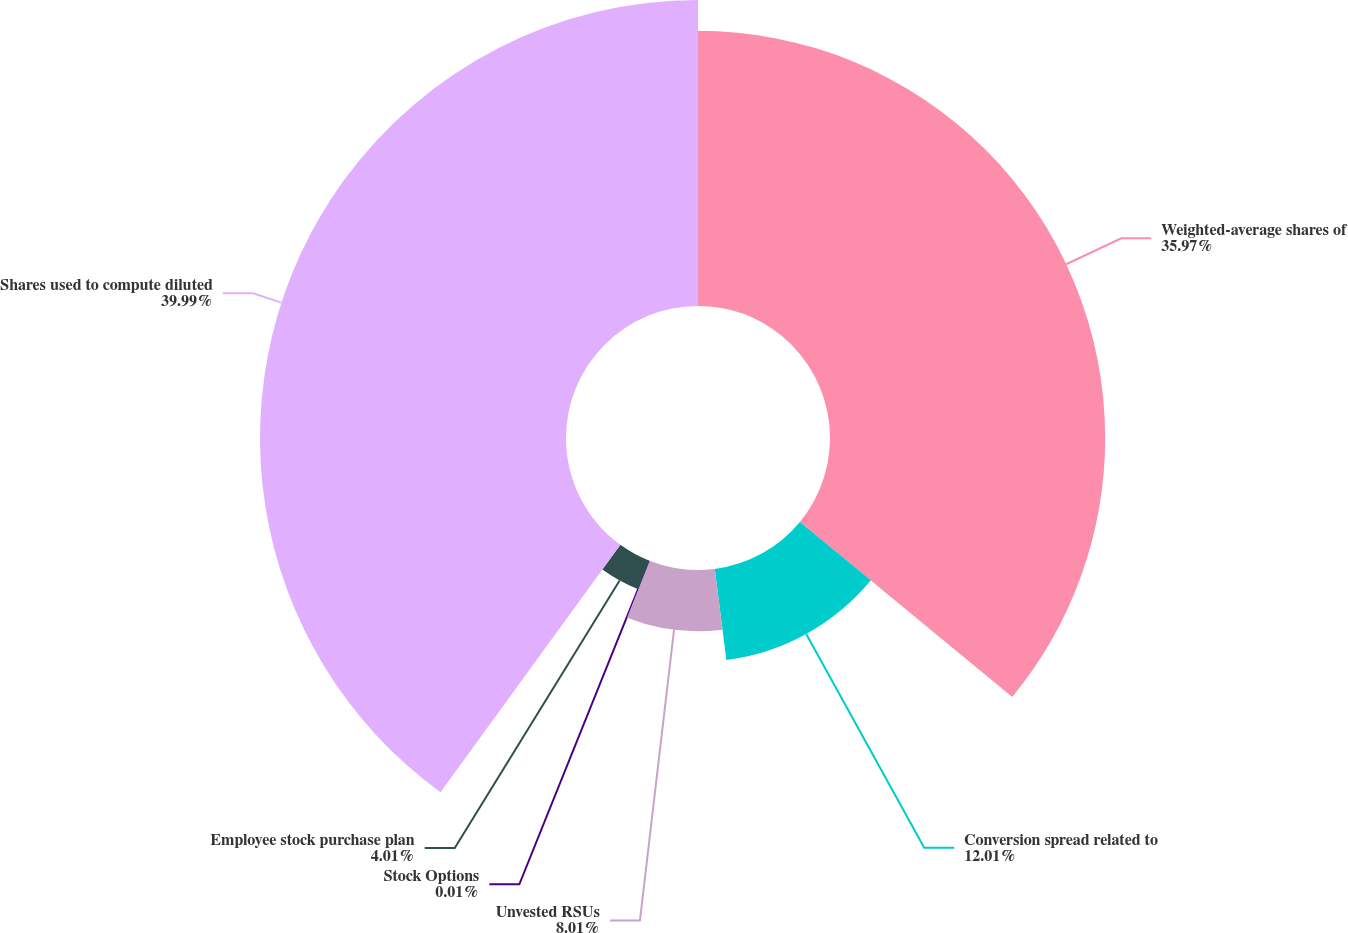Convert chart. <chart><loc_0><loc_0><loc_500><loc_500><pie_chart><fcel>Weighted-average shares of<fcel>Conversion spread related to<fcel>Unvested RSUs<fcel>Stock Options<fcel>Employee stock purchase plan<fcel>Shares used to compute diluted<nl><fcel>35.97%<fcel>12.01%<fcel>8.01%<fcel>0.01%<fcel>4.01%<fcel>40.0%<nl></chart> 